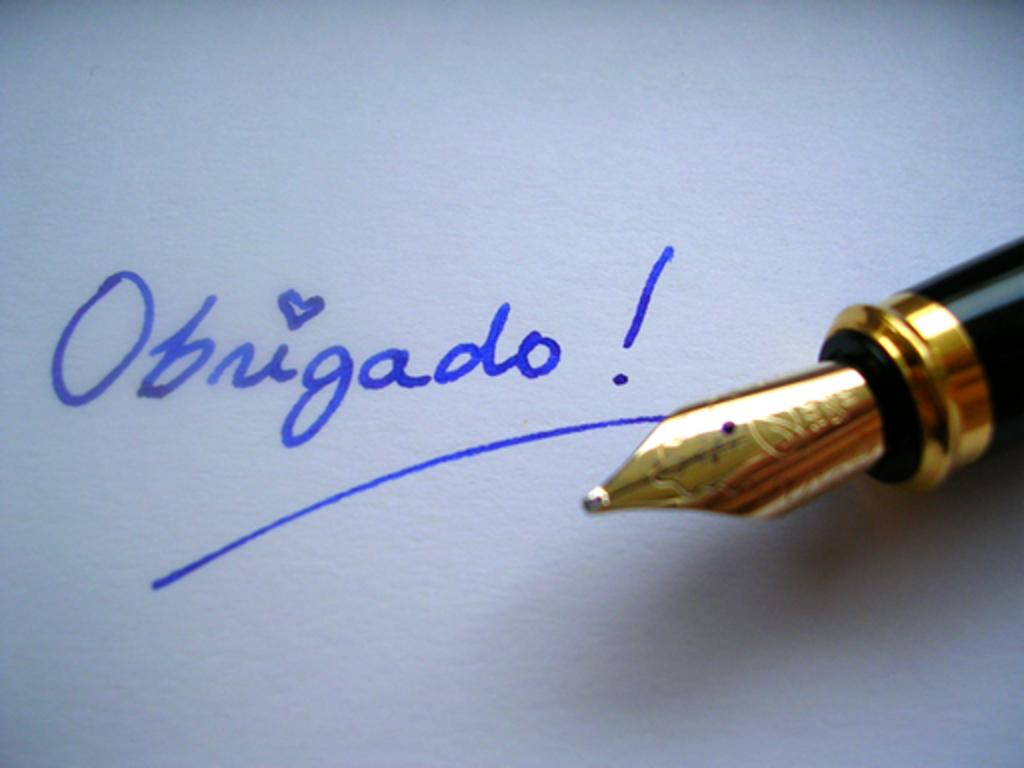What object is present in the image that is commonly used for writing? There is an ink pen in the image. What can be seen in the image that was created using the ink pen? There is writing in the image. What color is the ink used for the writing in the image? The ink used for the writing is blue. What type of eyes can be seen in the image? There are no eyes present in the image. Is there a basin visible in the image? There is no basin present in the image. 